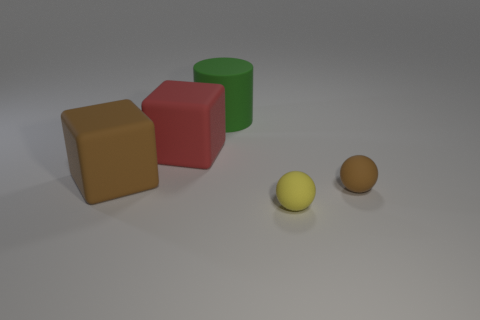Add 1 tiny brown matte spheres. How many objects exist? 6 Subtract all cubes. How many objects are left? 3 Subtract all purple cylinders. How many brown cubes are left? 1 Subtract all yellow objects. Subtract all yellow matte spheres. How many objects are left? 3 Add 4 matte spheres. How many matte spheres are left? 6 Add 5 gray spheres. How many gray spheres exist? 5 Subtract all yellow spheres. How many spheres are left? 1 Subtract 0 cyan blocks. How many objects are left? 5 Subtract 1 cubes. How many cubes are left? 1 Subtract all cyan cylinders. Subtract all blue cubes. How many cylinders are left? 1 